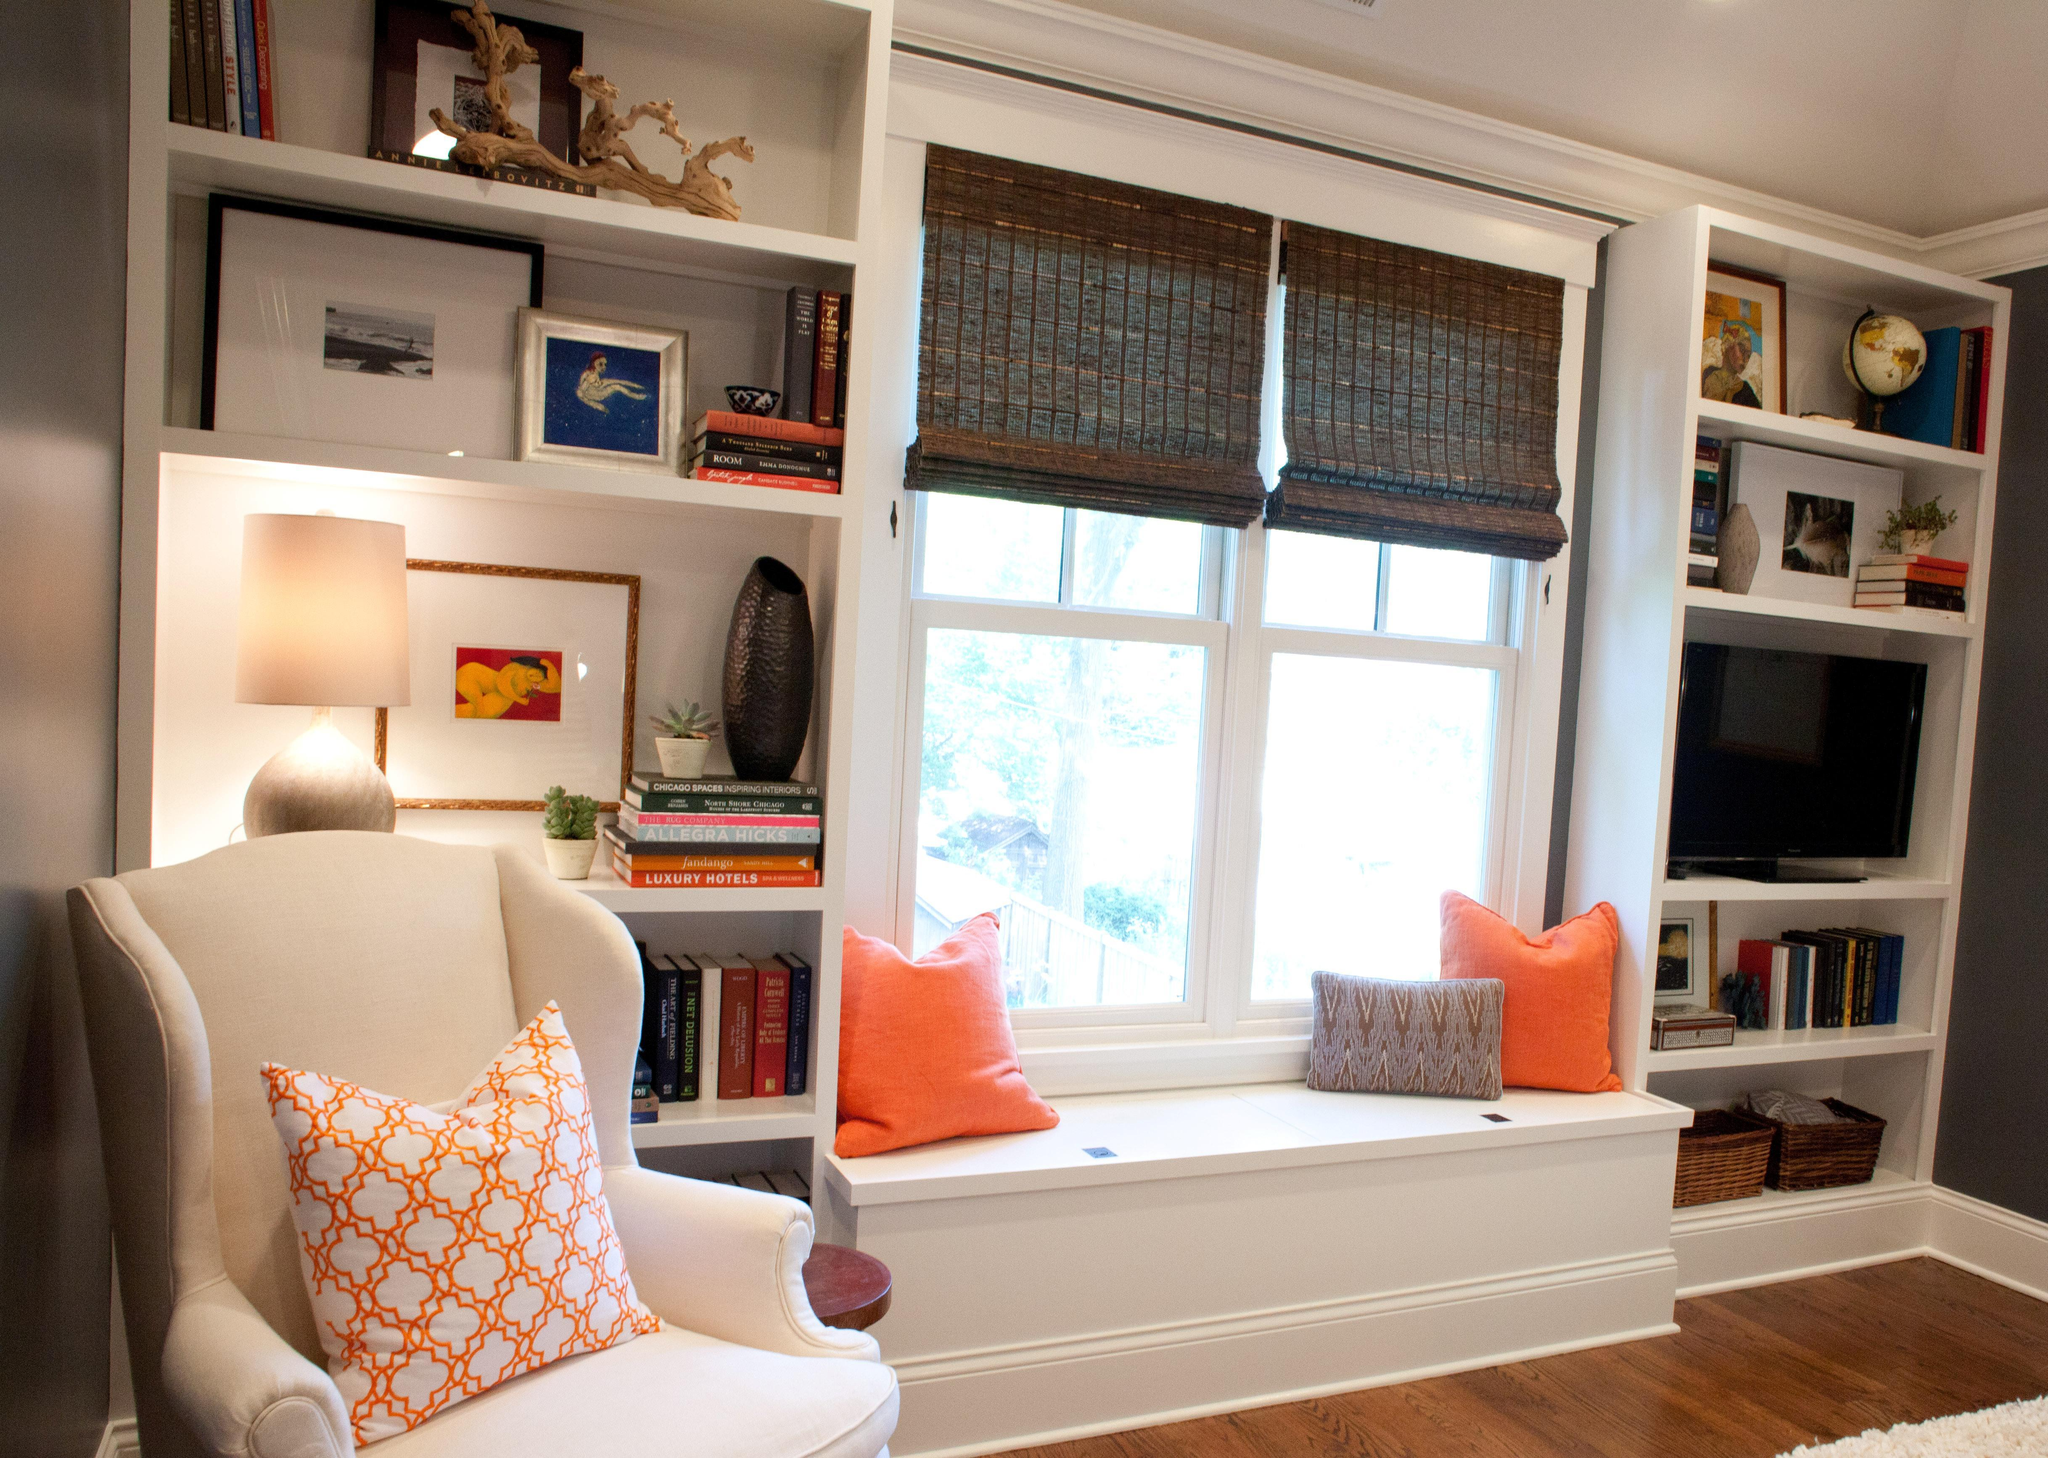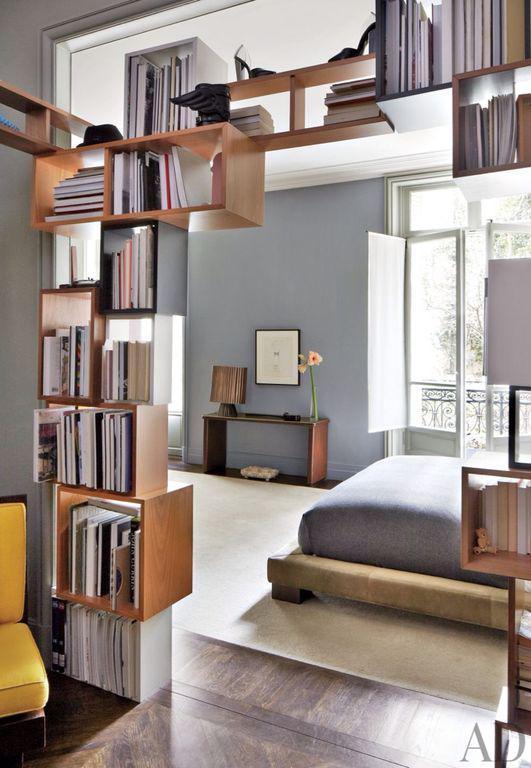The first image is the image on the left, the second image is the image on the right. For the images displayed, is the sentence "The bookshelf in the image on the right frame an arch." factually correct? Answer yes or no. Yes. The first image is the image on the left, the second image is the image on the right. Assess this claim about the two images: "An image shows a bed that extends from a recessed area created by bookshelves that surround it.". Correct or not? Answer yes or no. No. 